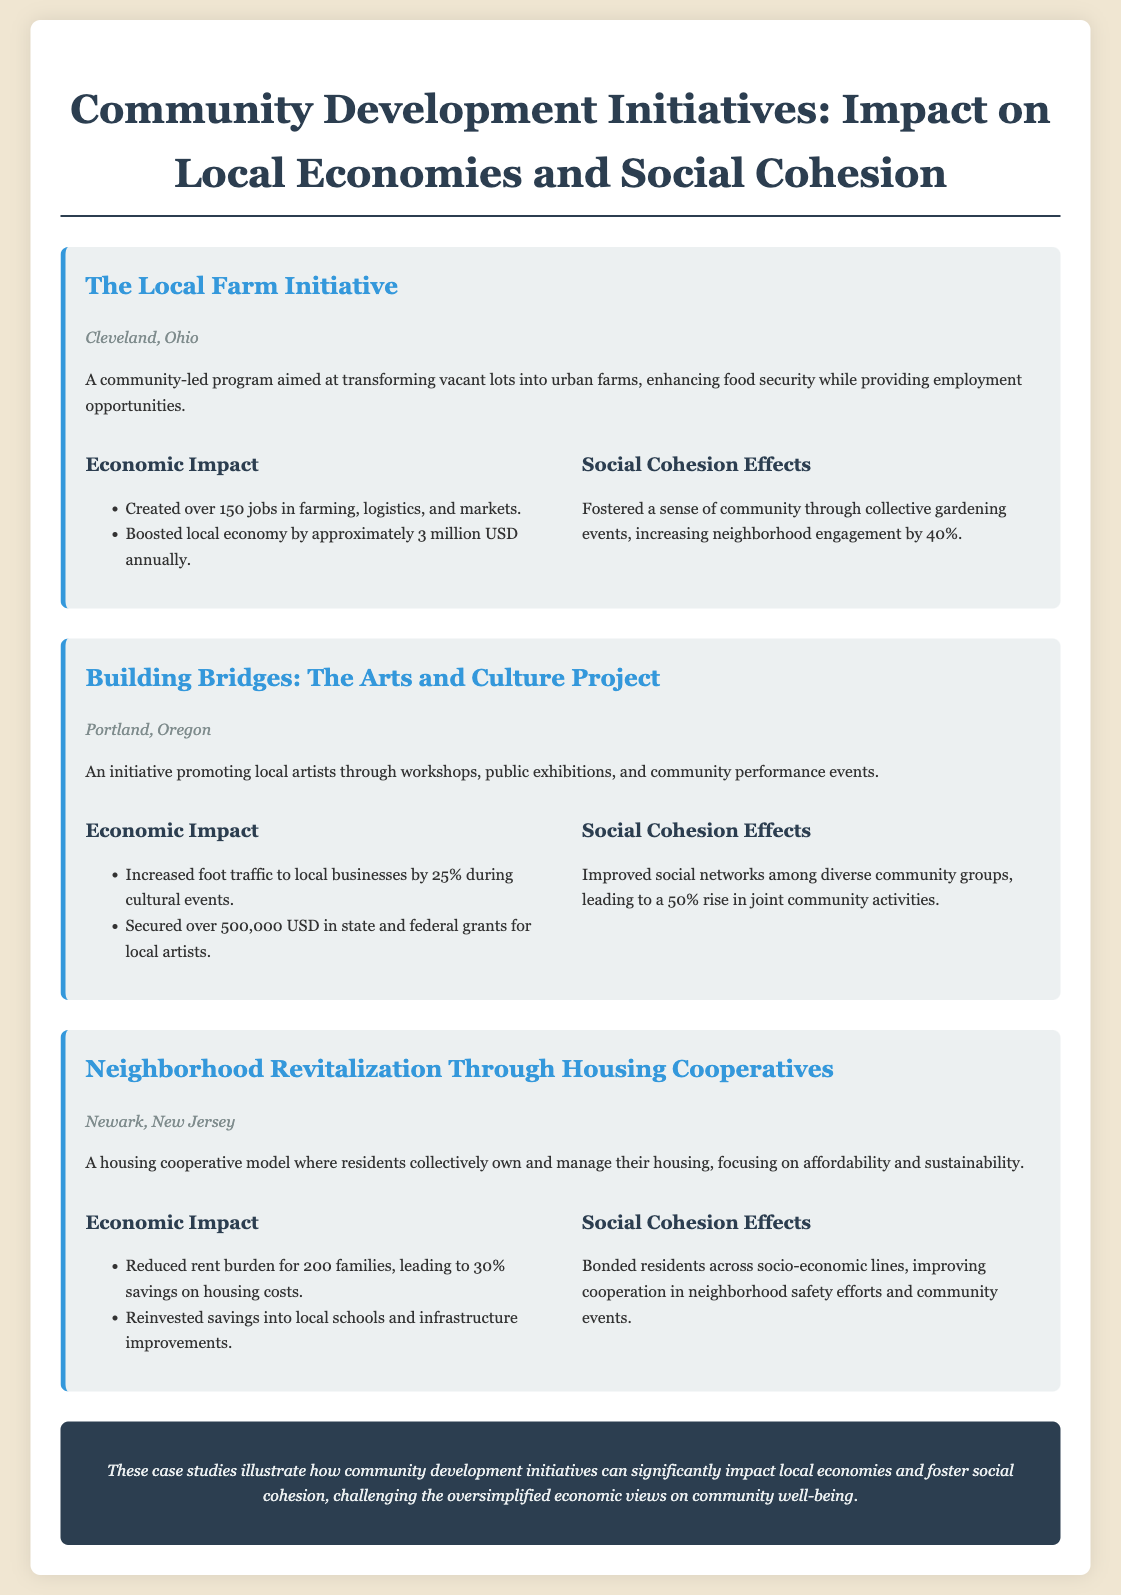What is the location of the Local Farm Initiative? The location is specified in the document as Cleveland, Ohio.
Answer: Cleveland, Ohio How many jobs were created by the Local Farm Initiative? The document states that over 150 jobs were created in various sectors related to the initiative.
Answer: 150 What was the impact on the local economy by the Local Farm Initiative? The document mentions a boosted local economy by approximately 3 million USD annually from this initiative.
Answer: 3 million USD What percentage increase in neighborhood engagement did the Local Farm Initiative achieve? It is indicated that neighborhood engagement increased by 40% through community gardening events.
Answer: 40% What funding amount was secured for local artists through the Arts and Culture Project? The document specifies that over 500,000 USD in grants were secured for local artists.
Answer: 500,000 USD What effect did the Arts and Culture Project have on joint community activities? The document reports a 50% rise in joint community activities among diverse groups.
Answer: 50% How many families benefited from reduced rent in the Housing Cooperatives initiative? The text states that 200 families experienced reduced rent burden from this initiative.
Answer: 200 What type of community effort improved neighborhood safety in Newark? The document mentions that residents bonded across socio-economic lines to improve cooperation in neighborhood safety efforts.
Answer: Cooperation What key conclusion does the document present about community development initiatives? The document concludes that these initiatives can significantly impact local economies and foster social cohesion, challenging oversimplified economic views.
Answer: Impact on local economies and social cohesion 